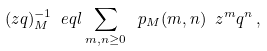<formula> <loc_0><loc_0><loc_500><loc_500>( z q ) _ { M } ^ { - 1 } \ e q l \sum _ { m , n \geq 0 } \ p _ { M } ( m , n ) \ z ^ { m } q ^ { n } \, ,</formula> 